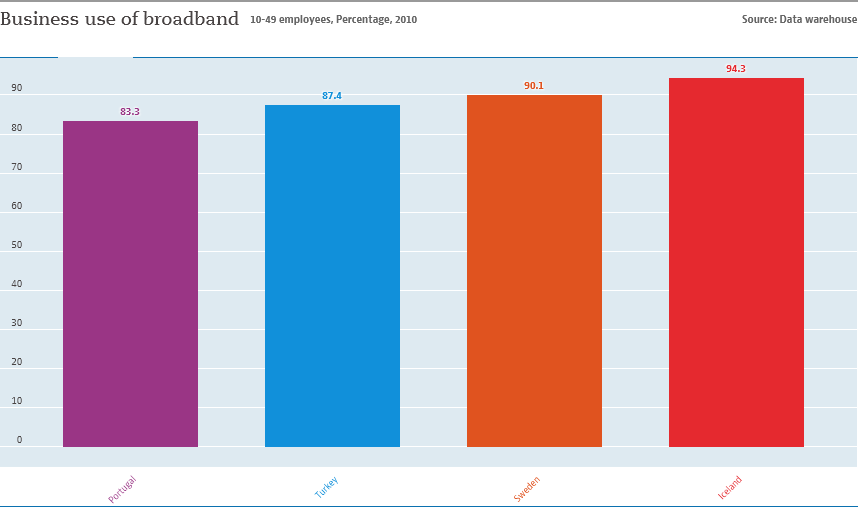Mention a couple of crucial points in this snapshot. The value of Portugal and Iceland is 11.. The color of the longest bar is red. 